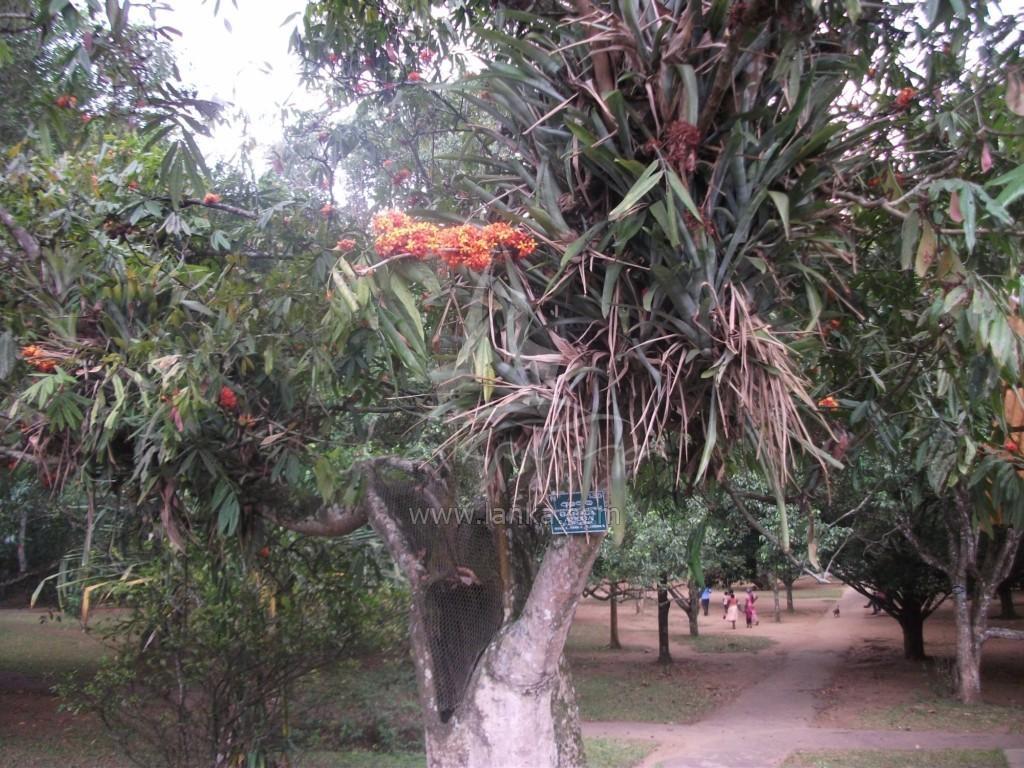In one or two sentences, can you explain what this image depicts? In the image to the front there is a tree with leaves and flowers. And in the background there are many trees. And also there are few people standing on the ground. 